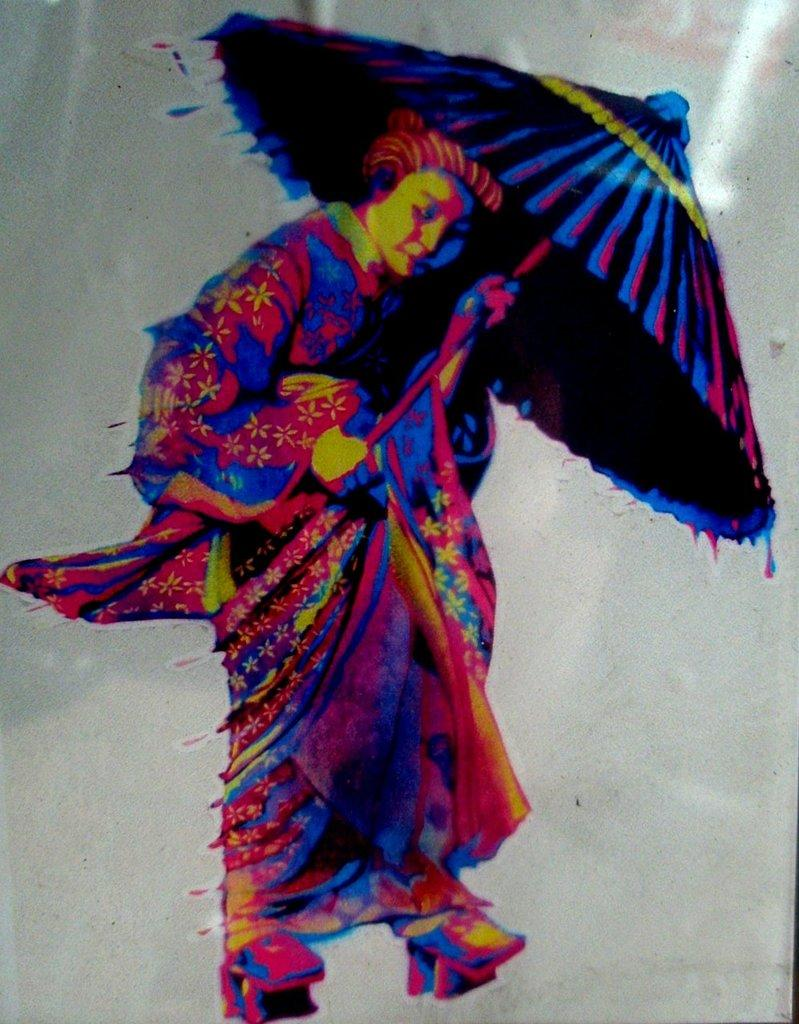What is the main subject of the image? There is a painting in the image. What is the painting depicting? The painting depicts a man holding an umbrella in his hands. What time of day is it in the painting? The time of day cannot be determined from the painting, as it is a static image and does not depict any specific time. 